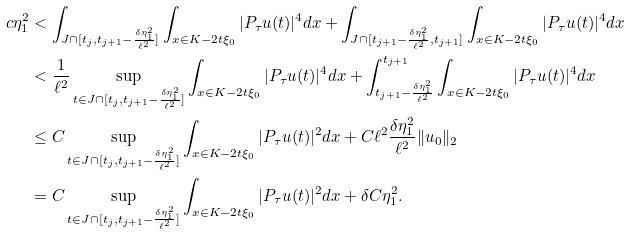<formula> <loc_0><loc_0><loc_500><loc_500>c \eta _ { 1 } ^ { 2 } & < \int _ { J \cap [ t _ { j } , t _ { j + 1 } - \frac { \delta \eta _ { 1 } ^ { 2 } } { \ell ^ { 2 } } ] } \int _ { x \in K - 2 t \xi _ { 0 } } | P _ { \tau } u ( t ) | ^ { 4 } d x + \int _ { J \cap [ t _ { j + 1 } - \frac { \delta \eta _ { 1 } ^ { 2 } } { \ell ^ { 2 } } , t _ { j + 1 } ] } \int _ { x \in K - 2 t \xi _ { 0 } } | P _ { \tau } u ( t ) | ^ { 4 } d x \\ & < \frac { 1 } { \ell ^ { 2 } } \sup _ { t \in J \cap [ t _ { j } , t _ { j + 1 } - \frac { \delta \eta _ { 1 } ^ { 2 } } { \ell ^ { 2 } } ] } \int _ { x \in K - 2 t \xi _ { 0 } } | P _ { \tau } u ( t ) | ^ { 4 } d x + \int _ { t _ { j + 1 } - \frac { \delta \eta _ { 1 } ^ { 2 } } { \ell ^ { 2 } } } ^ { t _ { j + 1 } } \int _ { x \in K - 2 t \xi _ { 0 } } | P _ { \tau } u ( t ) | ^ { 4 } d x \\ & \leq C \sup _ { t \in J \cap [ t _ { j } , t _ { j + 1 } - \frac { \delta \eta _ { 1 } ^ { 2 } } { \ell ^ { 2 } } ] } \int _ { x \in K - 2 t \xi _ { 0 } } | P _ { \tau } u ( t ) | ^ { 2 } d x + C \ell ^ { 2 } \frac { \delta \eta _ { 1 } ^ { 2 } } { \ell ^ { 2 } } \| u _ { 0 } \| _ { 2 } \\ & = C \sup _ { t \in J \cap [ t _ { j } , t _ { j + 1 } - \frac { \delta \eta _ { 1 } ^ { 2 } } { \ell ^ { 2 } } ] } \int _ { x \in K - 2 t \xi _ { 0 } } | P _ { \tau } u ( t ) | ^ { 2 } d x + \delta C \eta _ { 1 } ^ { 2 } .</formula> 